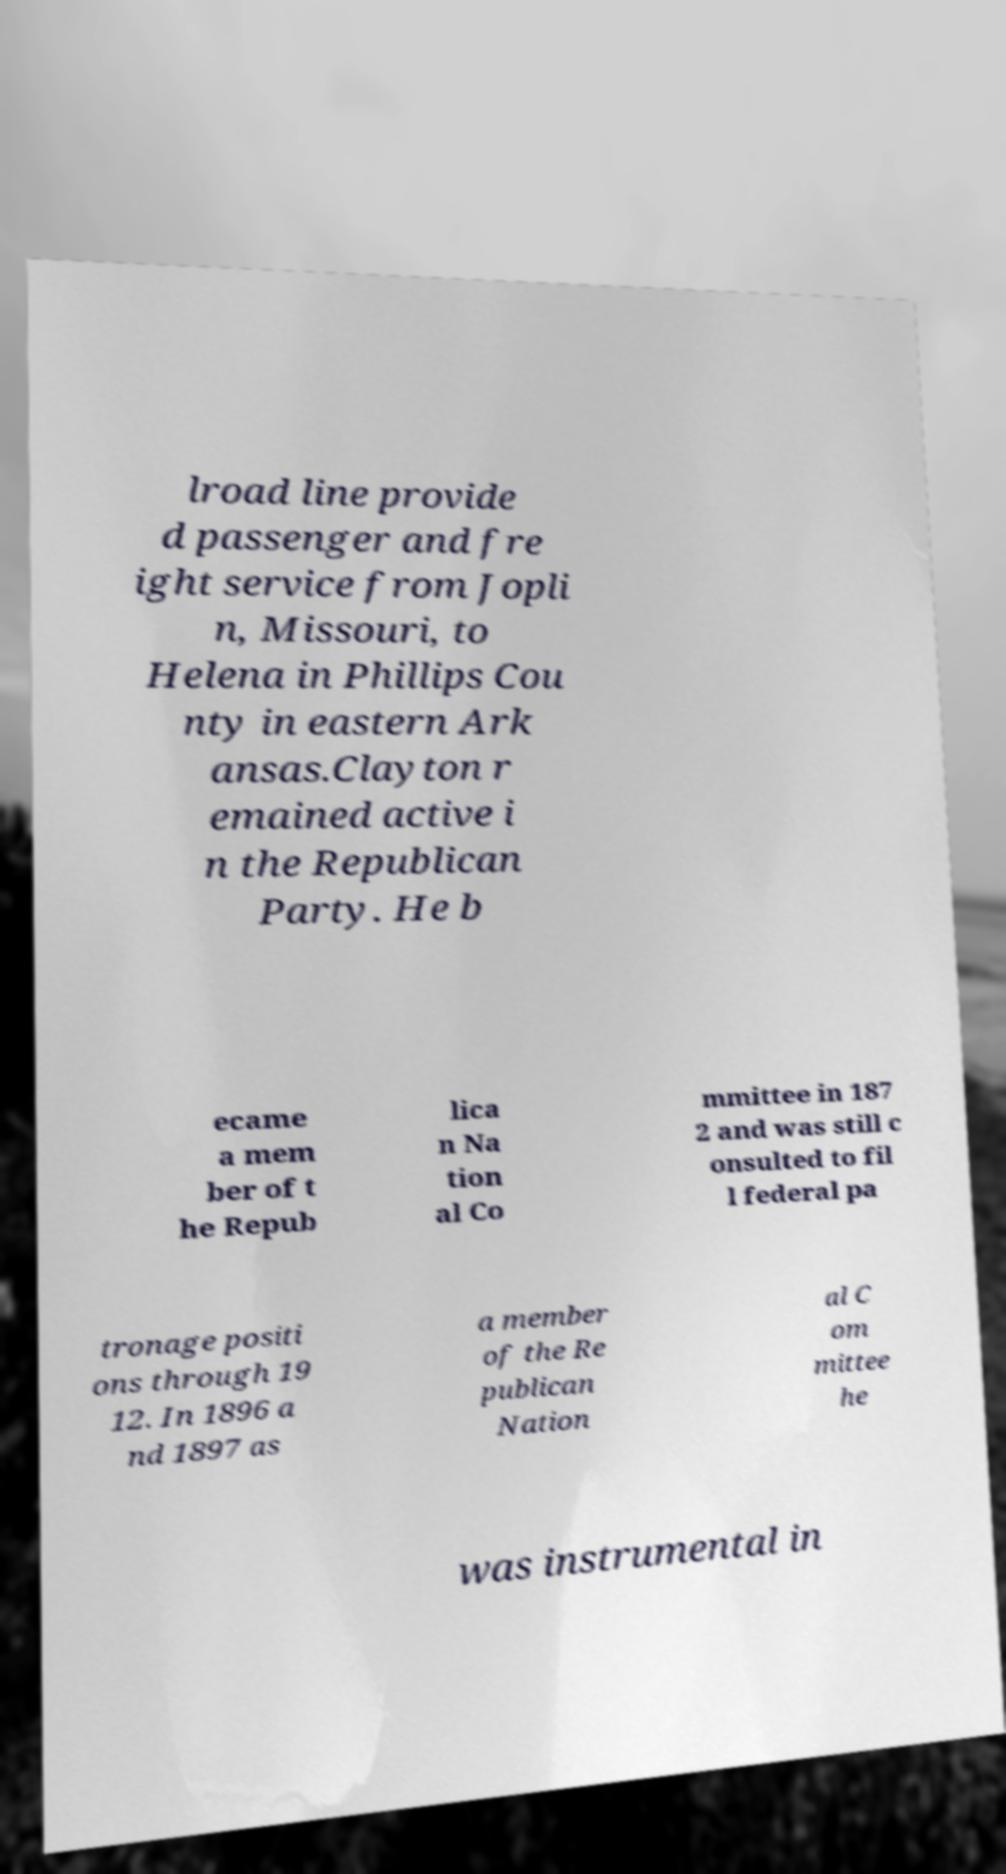Can you accurately transcribe the text from the provided image for me? lroad line provide d passenger and fre ight service from Jopli n, Missouri, to Helena in Phillips Cou nty in eastern Ark ansas.Clayton r emained active i n the Republican Party. He b ecame a mem ber of t he Repub lica n Na tion al Co mmittee in 187 2 and was still c onsulted to fil l federal pa tronage positi ons through 19 12. In 1896 a nd 1897 as a member of the Re publican Nation al C om mittee he was instrumental in 